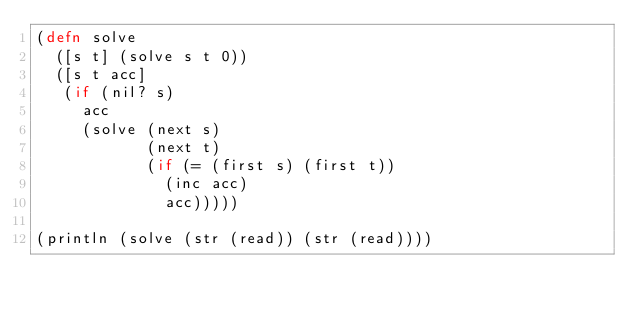<code> <loc_0><loc_0><loc_500><loc_500><_Clojure_>(defn solve
  ([s t] (solve s t 0))
  ([s t acc]
   (if (nil? s)
     acc
     (solve (next s)
            (next t)
            (if (= (first s) (first t))
              (inc acc)
              acc)))))

(println (solve (str (read)) (str (read))))
</code> 